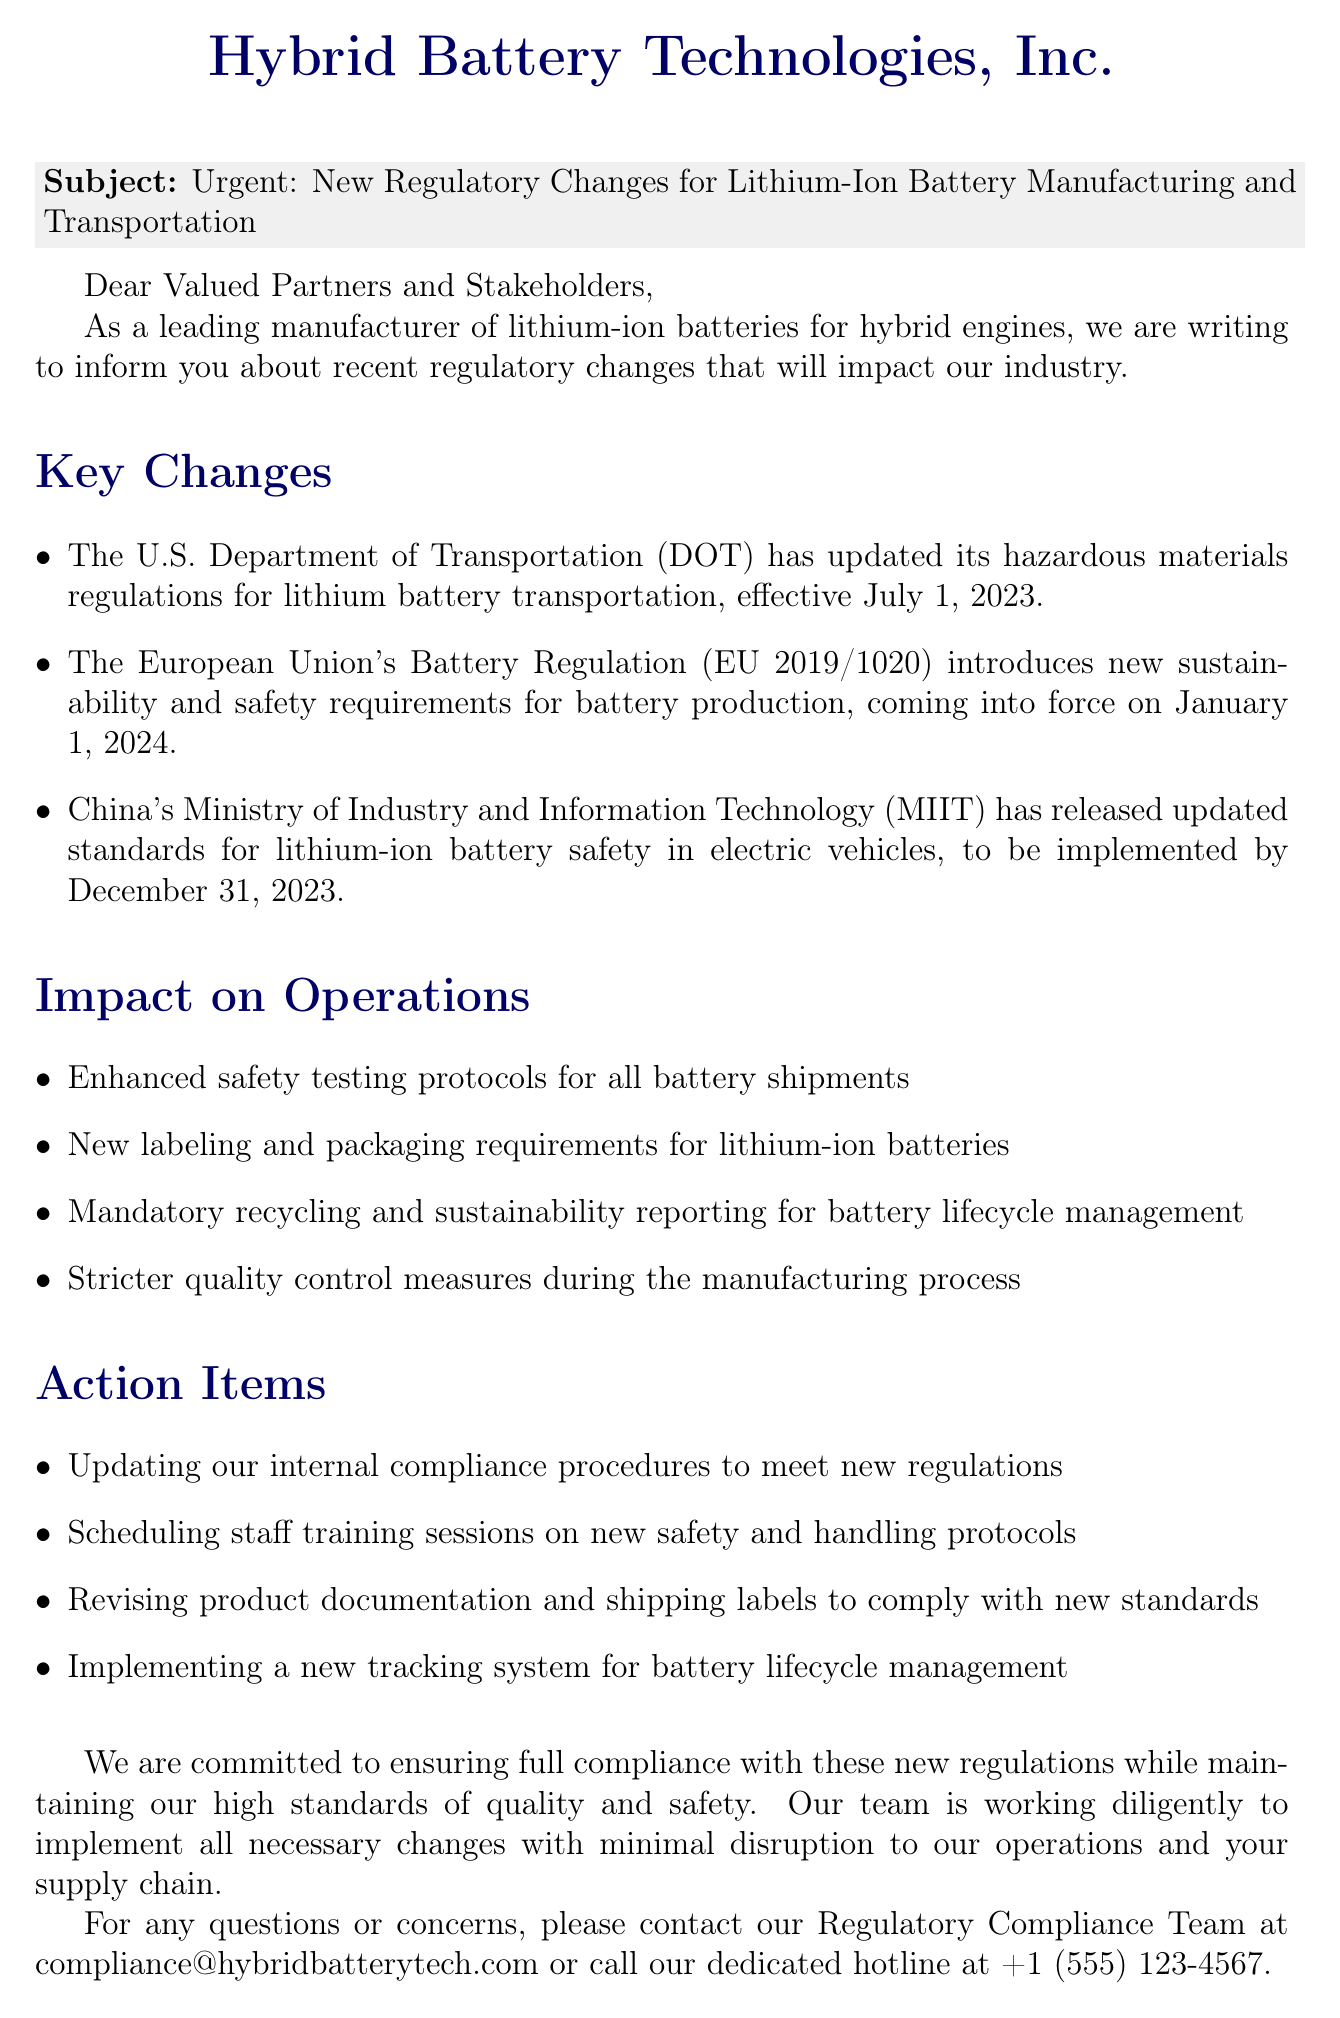What are the main new regulations discussed? The document lists three main regulations regarding lithium-ion battery manufacturing and transportation that have been updated or introduced.
Answer: U.S. DOT regulations, EU Battery Regulation, China's MIIT standards What is the effective date for the U.S. Department of Transportation regulation? The document provides a specific date when the U.S. Department of Transportation's regulation will take effect.
Answer: July 1, 2023 When will the EU's Battery Regulation come into force? The document states the date when the European Union's new regulation will be implemented.
Answer: January 1, 2024 What is one of the action items mentioned? The document lists several action items that the company plans to implement in response to the new regulations.
Answer: Updating internal compliance procedures Who is the contact for questions related to compliance? The document mentions a team that can be contacted for inquiries pertaining to regulatory changes.
Answer: Regulatory Compliance Team What additional training will be scheduled? The document outlines a specific training focus for staff in relation to new protocols due to regulation changes.
Answer: Safety and handling protocols What type of document is this? The structure and content of the document indicate its format and purpose.
Answer: Notification email What will be mandatory for battery lifecycle management? The document specifies what new requirements will be enforced regarding battery lifecycle.
Answer: Recycling and sustainability reporting What is the title of the person who signed the document? The document includes the signature of a person with a notable title at the company.
Answer: Director of Regulatory Affairs 